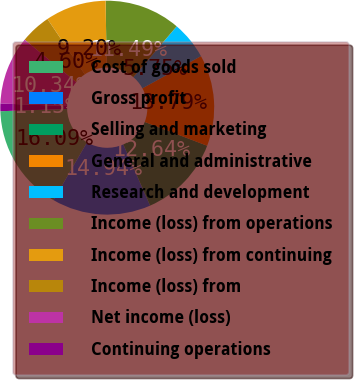Convert chart. <chart><loc_0><loc_0><loc_500><loc_500><pie_chart><fcel>Cost of goods sold<fcel>Gross profit<fcel>Selling and marketing<fcel>General and administrative<fcel>Research and development<fcel>Income (loss) from operations<fcel>Income (loss) from continuing<fcel>Income (loss) from<fcel>Net income (loss)<fcel>Continuing operations<nl><fcel>16.09%<fcel>14.94%<fcel>12.64%<fcel>13.79%<fcel>5.75%<fcel>11.49%<fcel>9.2%<fcel>4.6%<fcel>10.34%<fcel>1.15%<nl></chart> 